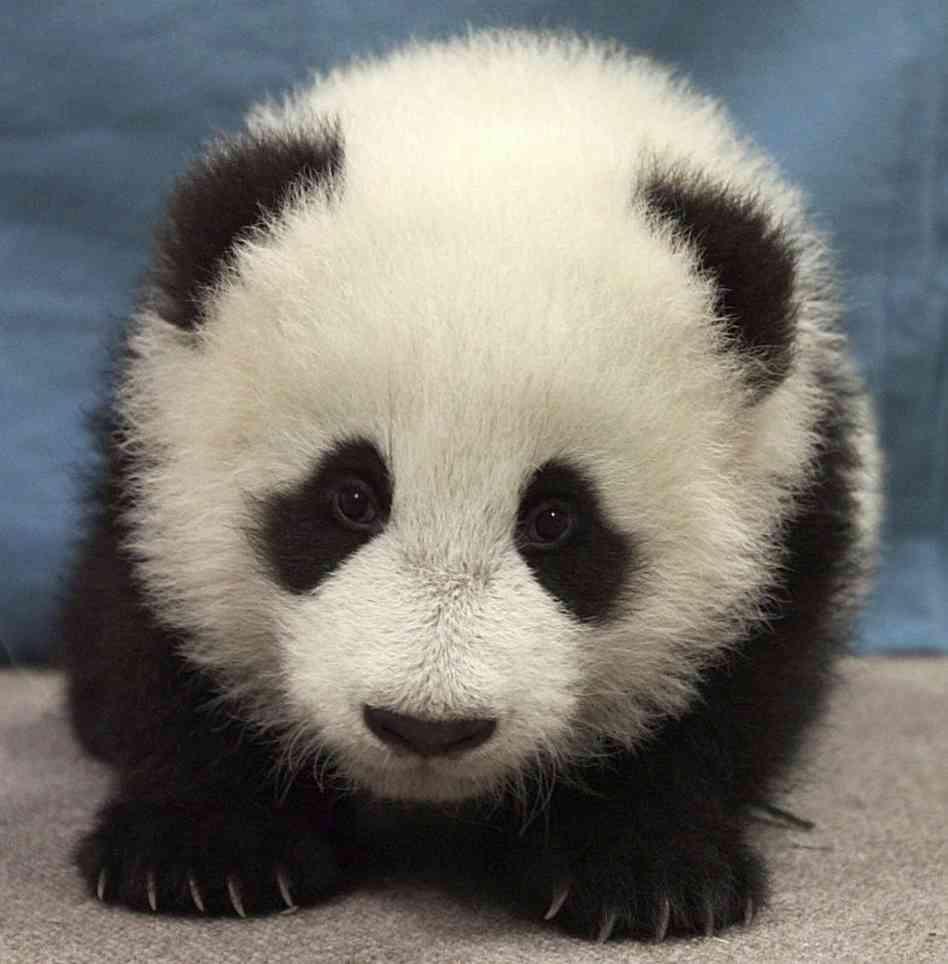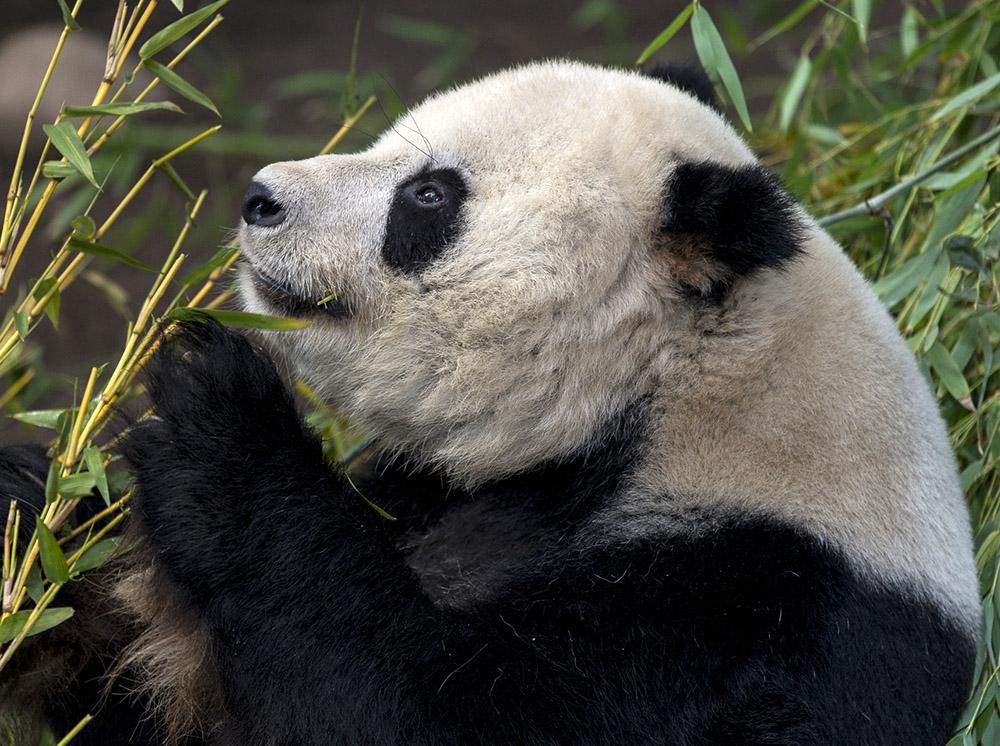The first image is the image on the left, the second image is the image on the right. Given the left and right images, does the statement "There are no people, only pandas, and one of the pandas is with plants." hold true? Answer yes or no. Yes. The first image is the image on the left, the second image is the image on the right. For the images displayed, is the sentence "There is at least one human face behind a panda bear." factually correct? Answer yes or no. No. 